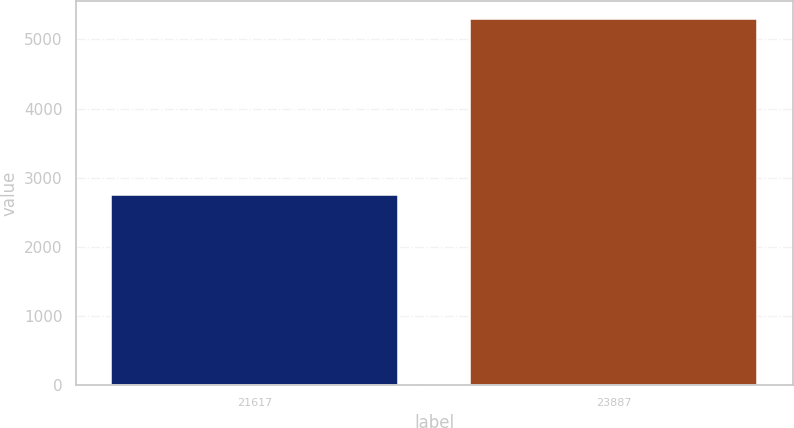Convert chart to OTSL. <chart><loc_0><loc_0><loc_500><loc_500><bar_chart><fcel>21617<fcel>23887<nl><fcel>2754<fcel>5290<nl></chart> 